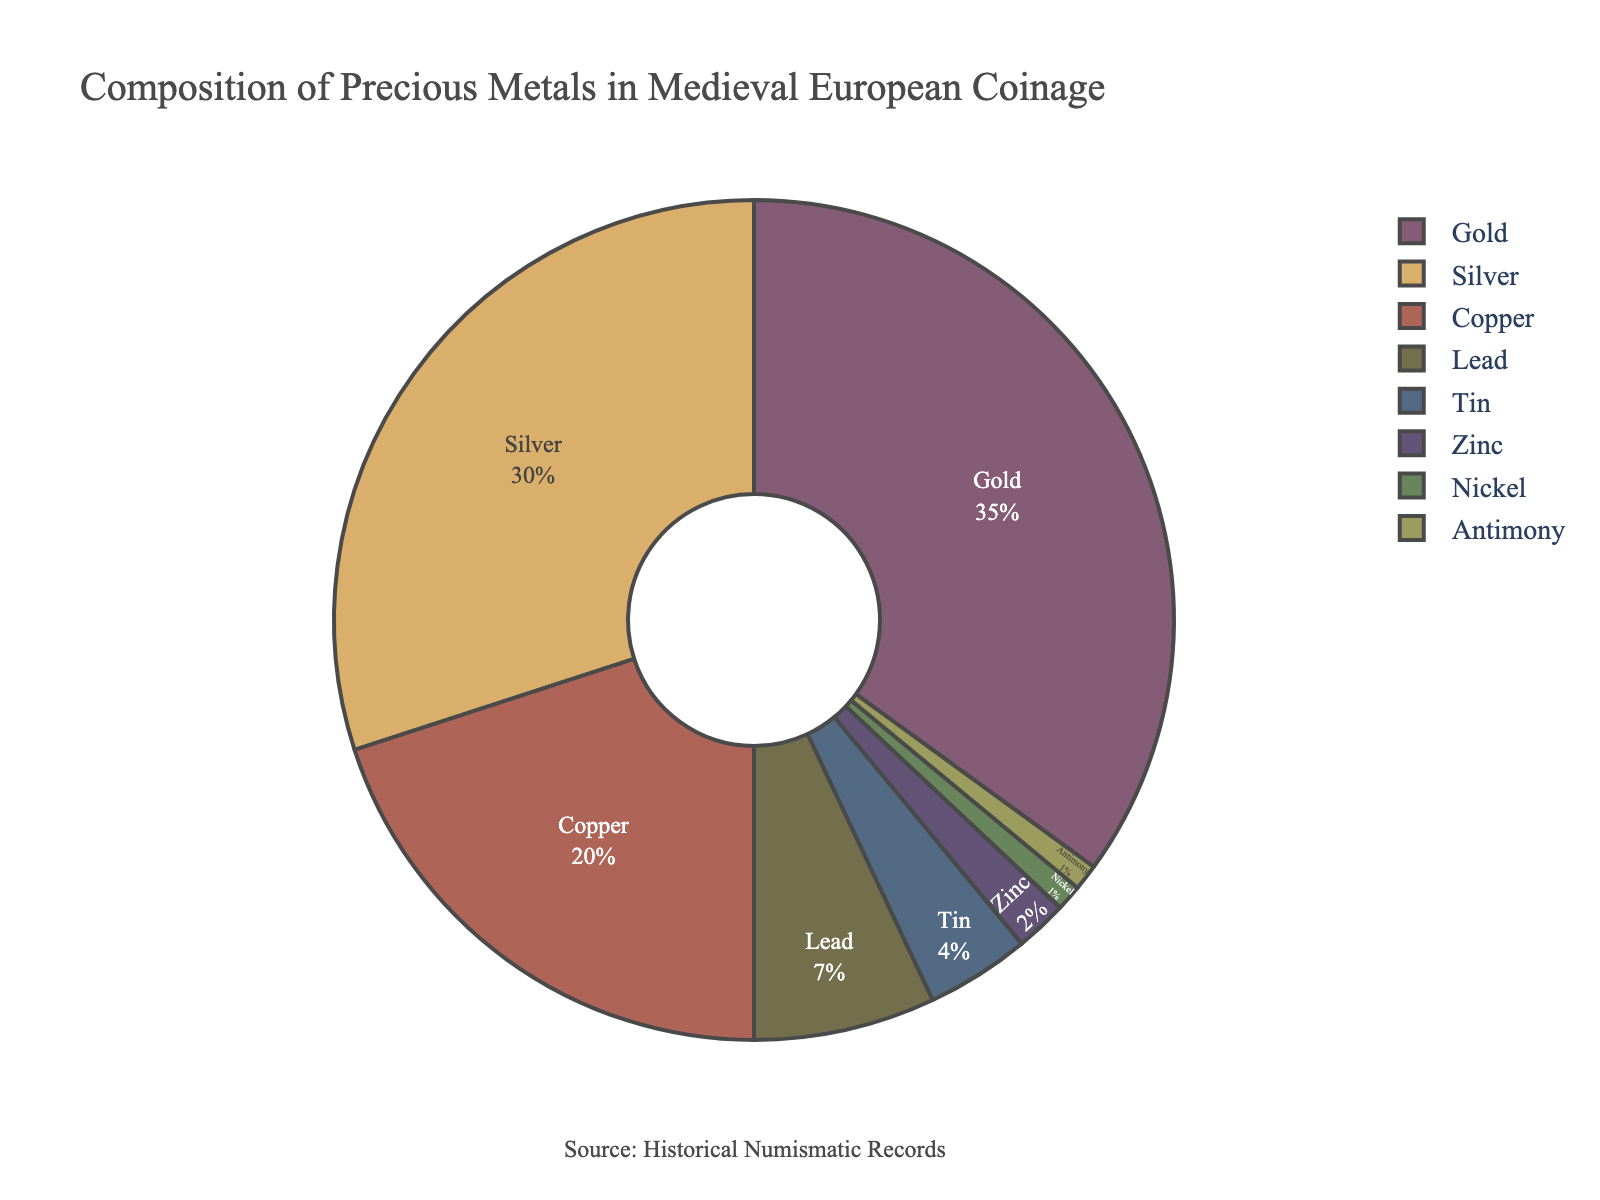What is the most common metal used in Medieval European coinage according to the pie chart? The largest segment on the pie chart represents gold, showing that it makes up the largest percentage of the composition.
Answer: Gold Which metals together make up more than half of the coinage composition? Gold and silver together make up 35% + 30% = 65%, which is more than half of the total composition.
Answer: Gold and Silver How does the percentage of copper compare to the combined percentage of tin and lead? Copper constitutes 20%, while tin and lead together make up 4% + 7% = 11%. Therefore, copper has a higher percentage.
Answer: Copper is greater What is the least common metal used in the coinage? The smallest segment on the pie chart represents nickel and antimony, each contributing only 1%.
Answer: Nickel and Antimony What is the total percentage of metals other than gold and silver? Summing all other metals: 20% (Copper) + 7% (Lead) + 4% (Tin) + 2% (Zinc) + 1% (Nickel) + 1% (Antimony) = 35%.
Answer: 35% What is the difference between the percentage of silver and copper? Silver makes up 30% of the coinage, while copper makes up 20%. The difference is 30% - 20% = 10%.
Answer: 10% Which metal has a higher percentage in the coinage: lead or zinc? Lead has a percentage of 7%, while zinc has a percentage of 2%. Therefore, lead has a higher percentage.
Answer: Lead If you combine the percentages of tin, zinc, nickel, and antimony, does it exceed the percentage of silver alone? Tin (4%) + Zinc (2%) + Nickel (1%) + Antimony (1%) = 8%. Silver alone is 30%, so the combined percentage is less than silver.
Answer: No By how much does the percentage of lead exceed the percentage of nickel? Lead represents 7% of the composition, while nickel represents 1%. The difference is 7% - 1% = 6%.
Answer: 6% Is there a metal used in less than 5% of the coinage but more than 2%? Tin fits this criterion as it is used in 4% of the coinage.
Answer: Tin 